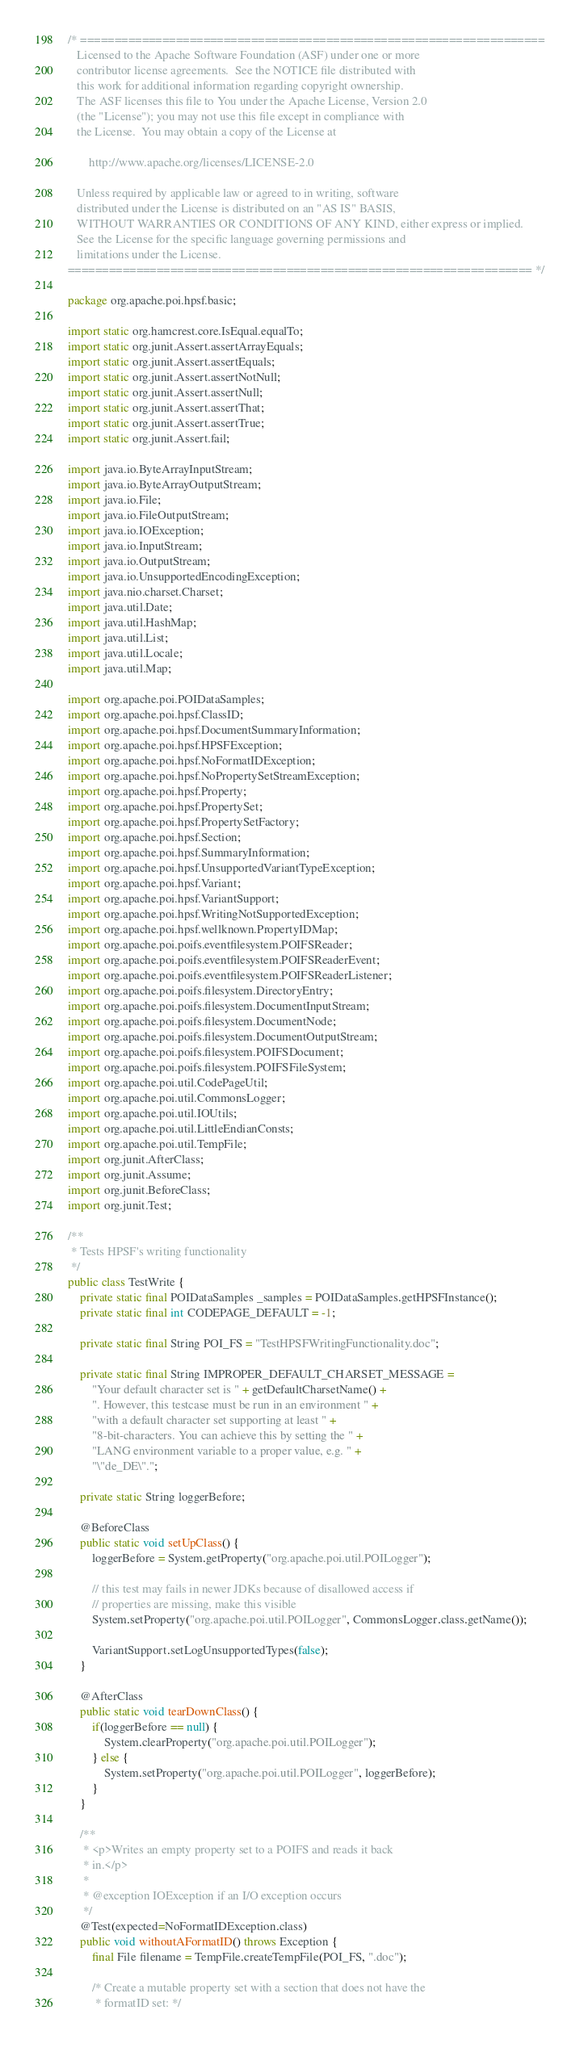<code> <loc_0><loc_0><loc_500><loc_500><_Java_>/* ====================================================================
   Licensed to the Apache Software Foundation (ASF) under one or more
   contributor license agreements.  See the NOTICE file distributed with
   this work for additional information regarding copyright ownership.
   The ASF licenses this file to You under the Apache License, Version 2.0
   (the "License"); you may not use this file except in compliance with
   the License.  You may obtain a copy of the License at

       http://www.apache.org/licenses/LICENSE-2.0

   Unless required by applicable law or agreed to in writing, software
   distributed under the License is distributed on an "AS IS" BASIS,
   WITHOUT WARRANTIES OR CONDITIONS OF ANY KIND, either express or implied.
   See the License for the specific language governing permissions and
   limitations under the License.
==================================================================== */

package org.apache.poi.hpsf.basic;

import static org.hamcrest.core.IsEqual.equalTo;
import static org.junit.Assert.assertArrayEquals;
import static org.junit.Assert.assertEquals;
import static org.junit.Assert.assertNotNull;
import static org.junit.Assert.assertNull;
import static org.junit.Assert.assertThat;
import static org.junit.Assert.assertTrue;
import static org.junit.Assert.fail;

import java.io.ByteArrayInputStream;
import java.io.ByteArrayOutputStream;
import java.io.File;
import java.io.FileOutputStream;
import java.io.IOException;
import java.io.InputStream;
import java.io.OutputStream;
import java.io.UnsupportedEncodingException;
import java.nio.charset.Charset;
import java.util.Date;
import java.util.HashMap;
import java.util.List;
import java.util.Locale;
import java.util.Map;

import org.apache.poi.POIDataSamples;
import org.apache.poi.hpsf.ClassID;
import org.apache.poi.hpsf.DocumentSummaryInformation;
import org.apache.poi.hpsf.HPSFException;
import org.apache.poi.hpsf.NoFormatIDException;
import org.apache.poi.hpsf.NoPropertySetStreamException;
import org.apache.poi.hpsf.Property;
import org.apache.poi.hpsf.PropertySet;
import org.apache.poi.hpsf.PropertySetFactory;
import org.apache.poi.hpsf.Section;
import org.apache.poi.hpsf.SummaryInformation;
import org.apache.poi.hpsf.UnsupportedVariantTypeException;
import org.apache.poi.hpsf.Variant;
import org.apache.poi.hpsf.VariantSupport;
import org.apache.poi.hpsf.WritingNotSupportedException;
import org.apache.poi.hpsf.wellknown.PropertyIDMap;
import org.apache.poi.poifs.eventfilesystem.POIFSReader;
import org.apache.poi.poifs.eventfilesystem.POIFSReaderEvent;
import org.apache.poi.poifs.eventfilesystem.POIFSReaderListener;
import org.apache.poi.poifs.filesystem.DirectoryEntry;
import org.apache.poi.poifs.filesystem.DocumentInputStream;
import org.apache.poi.poifs.filesystem.DocumentNode;
import org.apache.poi.poifs.filesystem.DocumentOutputStream;
import org.apache.poi.poifs.filesystem.POIFSDocument;
import org.apache.poi.poifs.filesystem.POIFSFileSystem;
import org.apache.poi.util.CodePageUtil;
import org.apache.poi.util.CommonsLogger;
import org.apache.poi.util.IOUtils;
import org.apache.poi.util.LittleEndianConsts;
import org.apache.poi.util.TempFile;
import org.junit.AfterClass;
import org.junit.Assume;
import org.junit.BeforeClass;
import org.junit.Test;

/**
 * Tests HPSF's writing functionality
 */
public class TestWrite {
    private static final POIDataSamples _samples = POIDataSamples.getHPSFInstance();
    private static final int CODEPAGE_DEFAULT = -1;

    private static final String POI_FS = "TestHPSFWritingFunctionality.doc";

    private static final String IMPROPER_DEFAULT_CHARSET_MESSAGE =
        "Your default character set is " + getDefaultCharsetName() +
        ". However, this testcase must be run in an environment " +
        "with a default character set supporting at least " +
        "8-bit-characters. You can achieve this by setting the " +
        "LANG environment variable to a proper value, e.g. " +
        "\"de_DE\".";

    private static String loggerBefore;

    @BeforeClass
    public static void setUpClass() {
        loggerBefore = System.getProperty("org.apache.poi.util.POILogger");

        // this test may fails in newer JDKs because of disallowed access if
        // properties are missing, make this visible
        System.setProperty("org.apache.poi.util.POILogger", CommonsLogger.class.getName());

        VariantSupport.setLogUnsupportedTypes(false);
    }

    @AfterClass
    public static void tearDownClass() {
        if(loggerBefore == null) {
            System.clearProperty("org.apache.poi.util.POILogger");
        } else {
            System.setProperty("org.apache.poi.util.POILogger", loggerBefore);
        }
    }
    
    /**
     * <p>Writes an empty property set to a POIFS and reads it back
     * in.</p>
     *
     * @exception IOException if an I/O exception occurs
     */
    @Test(expected=NoFormatIDException.class)
    public void withoutAFormatID() throws Exception {
        final File filename = TempFile.createTempFile(POI_FS, ".doc");

        /* Create a mutable property set with a section that does not have the
         * formatID set: */</code> 